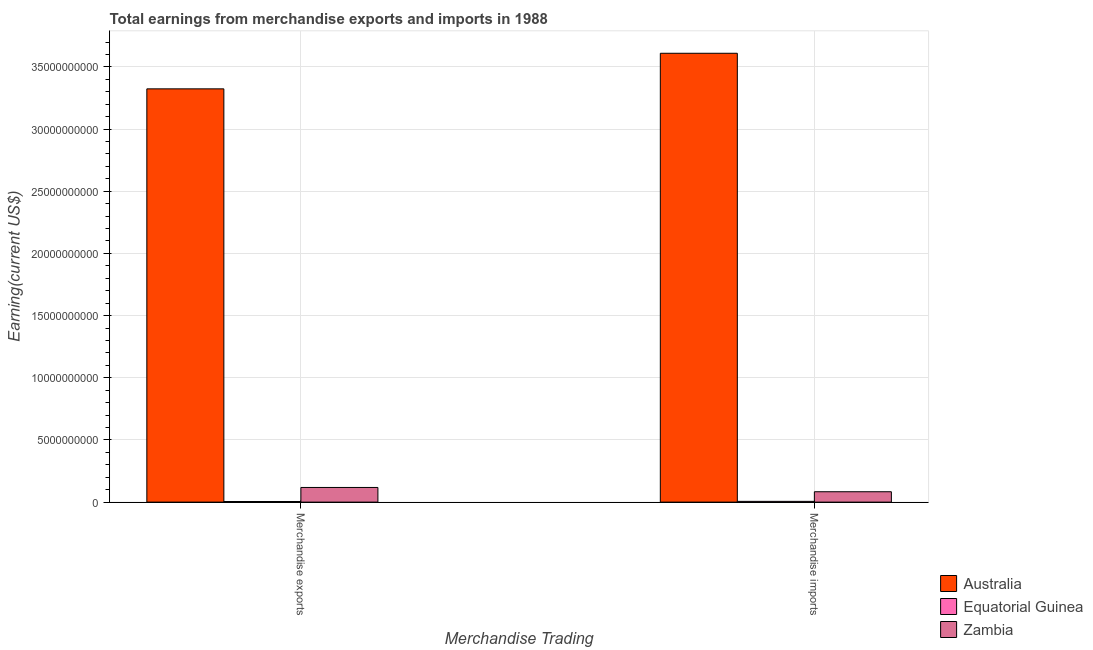Are the number of bars on each tick of the X-axis equal?
Your response must be concise. Yes. How many bars are there on the 1st tick from the right?
Your answer should be very brief. 3. What is the earnings from merchandise imports in Equatorial Guinea?
Your answer should be compact. 6.10e+07. Across all countries, what is the maximum earnings from merchandise exports?
Provide a short and direct response. 3.32e+1. Across all countries, what is the minimum earnings from merchandise imports?
Provide a short and direct response. 6.10e+07. In which country was the earnings from merchandise imports minimum?
Provide a short and direct response. Equatorial Guinea. What is the total earnings from merchandise exports in the graph?
Keep it short and to the point. 3.45e+1. What is the difference between the earnings from merchandise exports in Zambia and that in Equatorial Guinea?
Make the answer very short. 1.13e+09. What is the difference between the earnings from merchandise imports in Australia and the earnings from merchandise exports in Zambia?
Provide a short and direct response. 3.49e+1. What is the average earnings from merchandise imports per country?
Your answer should be compact. 1.23e+1. What is the difference between the earnings from merchandise imports and earnings from merchandise exports in Australia?
Your answer should be very brief. 2.86e+09. What is the ratio of the earnings from merchandise exports in Zambia to that in Australia?
Offer a very short reply. 0.04. What does the 2nd bar from the left in Merchandise imports represents?
Offer a very short reply. Equatorial Guinea. What does the 2nd bar from the right in Merchandise imports represents?
Provide a short and direct response. Equatorial Guinea. How many bars are there?
Give a very brief answer. 6. How many countries are there in the graph?
Offer a terse response. 3. Does the graph contain any zero values?
Make the answer very short. No. Does the graph contain grids?
Give a very brief answer. Yes. What is the title of the graph?
Your response must be concise. Total earnings from merchandise exports and imports in 1988. What is the label or title of the X-axis?
Give a very brief answer. Merchandise Trading. What is the label or title of the Y-axis?
Make the answer very short. Earning(current US$). What is the Earning(current US$) in Australia in Merchandise exports?
Provide a succinct answer. 3.32e+1. What is the Earning(current US$) of Equatorial Guinea in Merchandise exports?
Your response must be concise. 4.90e+07. What is the Earning(current US$) of Zambia in Merchandise exports?
Offer a very short reply. 1.18e+09. What is the Earning(current US$) of Australia in Merchandise imports?
Ensure brevity in your answer.  3.61e+1. What is the Earning(current US$) in Equatorial Guinea in Merchandise imports?
Your response must be concise. 6.10e+07. What is the Earning(current US$) in Zambia in Merchandise imports?
Keep it short and to the point. 8.35e+08. Across all Merchandise Trading, what is the maximum Earning(current US$) in Australia?
Offer a very short reply. 3.61e+1. Across all Merchandise Trading, what is the maximum Earning(current US$) of Equatorial Guinea?
Provide a short and direct response. 6.10e+07. Across all Merchandise Trading, what is the maximum Earning(current US$) of Zambia?
Your answer should be compact. 1.18e+09. Across all Merchandise Trading, what is the minimum Earning(current US$) of Australia?
Offer a very short reply. 3.32e+1. Across all Merchandise Trading, what is the minimum Earning(current US$) in Equatorial Guinea?
Give a very brief answer. 4.90e+07. Across all Merchandise Trading, what is the minimum Earning(current US$) in Zambia?
Provide a short and direct response. 8.35e+08. What is the total Earning(current US$) in Australia in the graph?
Keep it short and to the point. 6.93e+1. What is the total Earning(current US$) of Equatorial Guinea in the graph?
Offer a very short reply. 1.10e+08. What is the total Earning(current US$) of Zambia in the graph?
Give a very brief answer. 2.01e+09. What is the difference between the Earning(current US$) of Australia in Merchandise exports and that in Merchandise imports?
Your answer should be very brief. -2.86e+09. What is the difference between the Earning(current US$) in Equatorial Guinea in Merchandise exports and that in Merchandise imports?
Provide a short and direct response. -1.20e+07. What is the difference between the Earning(current US$) in Zambia in Merchandise exports and that in Merchandise imports?
Offer a terse response. 3.44e+08. What is the difference between the Earning(current US$) in Australia in Merchandise exports and the Earning(current US$) in Equatorial Guinea in Merchandise imports?
Your answer should be compact. 3.32e+1. What is the difference between the Earning(current US$) in Australia in Merchandise exports and the Earning(current US$) in Zambia in Merchandise imports?
Offer a terse response. 3.24e+1. What is the difference between the Earning(current US$) in Equatorial Guinea in Merchandise exports and the Earning(current US$) in Zambia in Merchandise imports?
Your answer should be compact. -7.86e+08. What is the average Earning(current US$) of Australia per Merchandise Trading?
Offer a terse response. 3.47e+1. What is the average Earning(current US$) of Equatorial Guinea per Merchandise Trading?
Give a very brief answer. 5.50e+07. What is the average Earning(current US$) in Zambia per Merchandise Trading?
Make the answer very short. 1.01e+09. What is the difference between the Earning(current US$) of Australia and Earning(current US$) of Equatorial Guinea in Merchandise exports?
Give a very brief answer. 3.32e+1. What is the difference between the Earning(current US$) in Australia and Earning(current US$) in Zambia in Merchandise exports?
Give a very brief answer. 3.21e+1. What is the difference between the Earning(current US$) in Equatorial Guinea and Earning(current US$) in Zambia in Merchandise exports?
Provide a short and direct response. -1.13e+09. What is the difference between the Earning(current US$) of Australia and Earning(current US$) of Equatorial Guinea in Merchandise imports?
Keep it short and to the point. 3.60e+1. What is the difference between the Earning(current US$) of Australia and Earning(current US$) of Zambia in Merchandise imports?
Offer a terse response. 3.53e+1. What is the difference between the Earning(current US$) of Equatorial Guinea and Earning(current US$) of Zambia in Merchandise imports?
Your answer should be compact. -7.74e+08. What is the ratio of the Earning(current US$) of Australia in Merchandise exports to that in Merchandise imports?
Make the answer very short. 0.92. What is the ratio of the Earning(current US$) in Equatorial Guinea in Merchandise exports to that in Merchandise imports?
Your answer should be compact. 0.8. What is the ratio of the Earning(current US$) of Zambia in Merchandise exports to that in Merchandise imports?
Give a very brief answer. 1.41. What is the difference between the highest and the second highest Earning(current US$) of Australia?
Offer a terse response. 2.86e+09. What is the difference between the highest and the second highest Earning(current US$) of Equatorial Guinea?
Your answer should be compact. 1.20e+07. What is the difference between the highest and the second highest Earning(current US$) in Zambia?
Your answer should be very brief. 3.44e+08. What is the difference between the highest and the lowest Earning(current US$) in Australia?
Offer a very short reply. 2.86e+09. What is the difference between the highest and the lowest Earning(current US$) in Zambia?
Ensure brevity in your answer.  3.44e+08. 